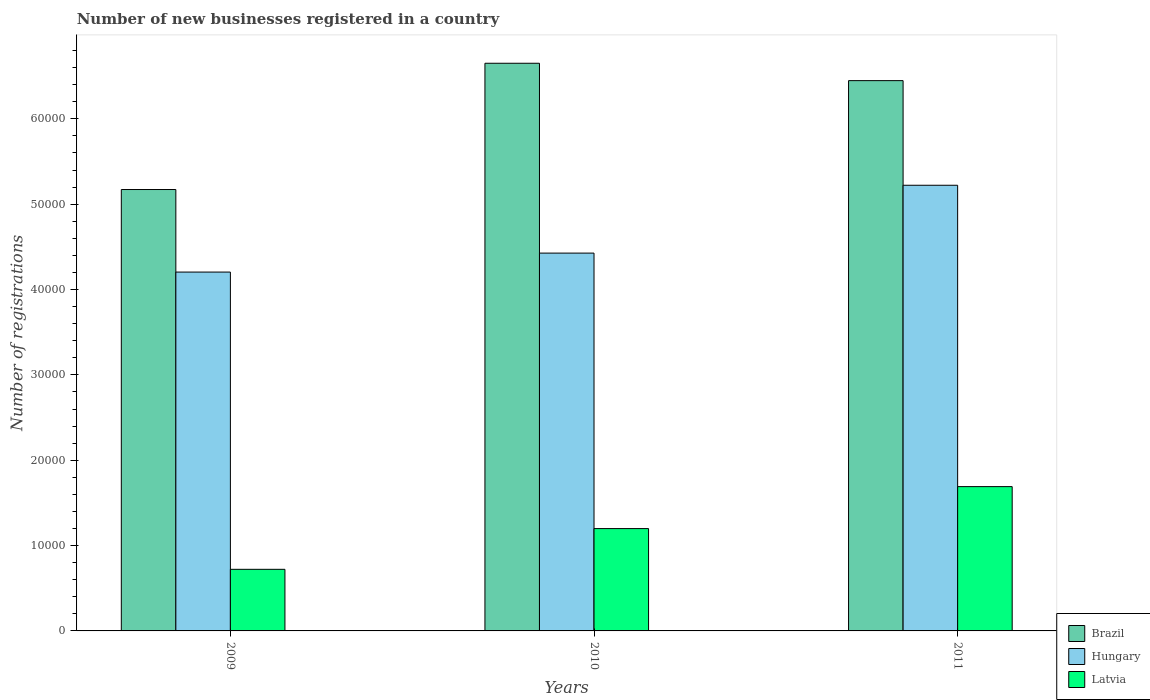How many groups of bars are there?
Offer a very short reply. 3. Are the number of bars on each tick of the X-axis equal?
Offer a terse response. Yes. How many bars are there on the 2nd tick from the left?
Provide a succinct answer. 3. What is the label of the 3rd group of bars from the left?
Provide a succinct answer. 2011. What is the number of new businesses registered in Brazil in 2011?
Ensure brevity in your answer.  6.45e+04. Across all years, what is the maximum number of new businesses registered in Hungary?
Keep it short and to the point. 5.22e+04. Across all years, what is the minimum number of new businesses registered in Hungary?
Your response must be concise. 4.20e+04. What is the total number of new businesses registered in Latvia in the graph?
Offer a very short reply. 3.61e+04. What is the difference between the number of new businesses registered in Brazil in 2009 and that in 2011?
Make the answer very short. -1.28e+04. What is the difference between the number of new businesses registered in Latvia in 2011 and the number of new businesses registered in Hungary in 2010?
Make the answer very short. -2.74e+04. What is the average number of new businesses registered in Hungary per year?
Ensure brevity in your answer.  4.62e+04. In the year 2011, what is the difference between the number of new businesses registered in Hungary and number of new businesses registered in Brazil?
Provide a succinct answer. -1.23e+04. What is the ratio of the number of new businesses registered in Latvia in 2009 to that in 2011?
Your answer should be very brief. 0.43. Is the number of new businesses registered in Brazil in 2010 less than that in 2011?
Provide a short and direct response. No. What is the difference between the highest and the second highest number of new businesses registered in Latvia?
Your answer should be very brief. 4918. What is the difference between the highest and the lowest number of new businesses registered in Latvia?
Make the answer very short. 9690. Is the sum of the number of new businesses registered in Latvia in 2010 and 2011 greater than the maximum number of new businesses registered in Hungary across all years?
Give a very brief answer. No. What does the 1st bar from the left in 2009 represents?
Provide a short and direct response. Brazil. What does the 2nd bar from the right in 2011 represents?
Provide a succinct answer. Hungary. Is it the case that in every year, the sum of the number of new businesses registered in Brazil and number of new businesses registered in Hungary is greater than the number of new businesses registered in Latvia?
Provide a succinct answer. Yes. How many bars are there?
Your response must be concise. 9. Are all the bars in the graph horizontal?
Your answer should be very brief. No. Are the values on the major ticks of Y-axis written in scientific E-notation?
Give a very brief answer. No. Does the graph contain grids?
Make the answer very short. No. Where does the legend appear in the graph?
Offer a terse response. Bottom right. How many legend labels are there?
Ensure brevity in your answer.  3. What is the title of the graph?
Give a very brief answer. Number of new businesses registered in a country. Does "Cote d'Ivoire" appear as one of the legend labels in the graph?
Offer a terse response. No. What is the label or title of the X-axis?
Ensure brevity in your answer.  Years. What is the label or title of the Y-axis?
Keep it short and to the point. Number of registrations. What is the Number of registrations of Brazil in 2009?
Give a very brief answer. 5.17e+04. What is the Number of registrations in Hungary in 2009?
Ensure brevity in your answer.  4.20e+04. What is the Number of registrations in Latvia in 2009?
Keep it short and to the point. 7218. What is the Number of registrations of Brazil in 2010?
Make the answer very short. 6.65e+04. What is the Number of registrations in Hungary in 2010?
Provide a succinct answer. 4.43e+04. What is the Number of registrations of Latvia in 2010?
Your response must be concise. 1.20e+04. What is the Number of registrations of Brazil in 2011?
Offer a very short reply. 6.45e+04. What is the Number of registrations of Hungary in 2011?
Offer a terse response. 5.22e+04. What is the Number of registrations of Latvia in 2011?
Give a very brief answer. 1.69e+04. Across all years, what is the maximum Number of registrations in Brazil?
Provide a succinct answer. 6.65e+04. Across all years, what is the maximum Number of registrations of Hungary?
Your answer should be very brief. 5.22e+04. Across all years, what is the maximum Number of registrations of Latvia?
Offer a very short reply. 1.69e+04. Across all years, what is the minimum Number of registrations in Brazil?
Offer a very short reply. 5.17e+04. Across all years, what is the minimum Number of registrations in Hungary?
Keep it short and to the point. 4.20e+04. Across all years, what is the minimum Number of registrations in Latvia?
Ensure brevity in your answer.  7218. What is the total Number of registrations of Brazil in the graph?
Your answer should be very brief. 1.83e+05. What is the total Number of registrations of Hungary in the graph?
Offer a terse response. 1.39e+05. What is the total Number of registrations in Latvia in the graph?
Provide a succinct answer. 3.61e+04. What is the difference between the Number of registrations in Brazil in 2009 and that in 2010?
Provide a succinct answer. -1.48e+04. What is the difference between the Number of registrations of Hungary in 2009 and that in 2010?
Your answer should be very brief. -2223. What is the difference between the Number of registrations in Latvia in 2009 and that in 2010?
Provide a succinct answer. -4772. What is the difference between the Number of registrations of Brazil in 2009 and that in 2011?
Offer a very short reply. -1.28e+04. What is the difference between the Number of registrations in Hungary in 2009 and that in 2011?
Your response must be concise. -1.02e+04. What is the difference between the Number of registrations in Latvia in 2009 and that in 2011?
Offer a terse response. -9690. What is the difference between the Number of registrations in Brazil in 2010 and that in 2011?
Offer a terse response. 2036. What is the difference between the Number of registrations of Hungary in 2010 and that in 2011?
Your answer should be compact. -7948. What is the difference between the Number of registrations in Latvia in 2010 and that in 2011?
Provide a short and direct response. -4918. What is the difference between the Number of registrations of Brazil in 2009 and the Number of registrations of Hungary in 2010?
Provide a short and direct response. 7448. What is the difference between the Number of registrations in Brazil in 2009 and the Number of registrations in Latvia in 2010?
Your response must be concise. 3.97e+04. What is the difference between the Number of registrations in Hungary in 2009 and the Number of registrations in Latvia in 2010?
Your response must be concise. 3.01e+04. What is the difference between the Number of registrations in Brazil in 2009 and the Number of registrations in Hungary in 2011?
Your answer should be compact. -500. What is the difference between the Number of registrations of Brazil in 2009 and the Number of registrations of Latvia in 2011?
Keep it short and to the point. 3.48e+04. What is the difference between the Number of registrations of Hungary in 2009 and the Number of registrations of Latvia in 2011?
Ensure brevity in your answer.  2.51e+04. What is the difference between the Number of registrations of Brazil in 2010 and the Number of registrations of Hungary in 2011?
Your answer should be compact. 1.43e+04. What is the difference between the Number of registrations of Brazil in 2010 and the Number of registrations of Latvia in 2011?
Keep it short and to the point. 4.96e+04. What is the difference between the Number of registrations in Hungary in 2010 and the Number of registrations in Latvia in 2011?
Your response must be concise. 2.74e+04. What is the average Number of registrations in Brazil per year?
Ensure brevity in your answer.  6.09e+04. What is the average Number of registrations in Hungary per year?
Offer a terse response. 4.62e+04. What is the average Number of registrations in Latvia per year?
Provide a succinct answer. 1.20e+04. In the year 2009, what is the difference between the Number of registrations of Brazil and Number of registrations of Hungary?
Your response must be concise. 9671. In the year 2009, what is the difference between the Number of registrations of Brazil and Number of registrations of Latvia?
Ensure brevity in your answer.  4.45e+04. In the year 2009, what is the difference between the Number of registrations in Hungary and Number of registrations in Latvia?
Provide a succinct answer. 3.48e+04. In the year 2010, what is the difference between the Number of registrations in Brazil and Number of registrations in Hungary?
Your answer should be compact. 2.22e+04. In the year 2010, what is the difference between the Number of registrations in Brazil and Number of registrations in Latvia?
Offer a terse response. 5.45e+04. In the year 2010, what is the difference between the Number of registrations of Hungary and Number of registrations of Latvia?
Your answer should be compact. 3.23e+04. In the year 2011, what is the difference between the Number of registrations of Brazil and Number of registrations of Hungary?
Your response must be concise. 1.23e+04. In the year 2011, what is the difference between the Number of registrations in Brazil and Number of registrations in Latvia?
Keep it short and to the point. 4.76e+04. In the year 2011, what is the difference between the Number of registrations of Hungary and Number of registrations of Latvia?
Provide a succinct answer. 3.53e+04. What is the ratio of the Number of registrations in Brazil in 2009 to that in 2010?
Offer a terse response. 0.78. What is the ratio of the Number of registrations of Hungary in 2009 to that in 2010?
Offer a terse response. 0.95. What is the ratio of the Number of registrations in Latvia in 2009 to that in 2010?
Your answer should be very brief. 0.6. What is the ratio of the Number of registrations in Brazil in 2009 to that in 2011?
Give a very brief answer. 0.8. What is the ratio of the Number of registrations in Hungary in 2009 to that in 2011?
Give a very brief answer. 0.81. What is the ratio of the Number of registrations in Latvia in 2009 to that in 2011?
Your response must be concise. 0.43. What is the ratio of the Number of registrations of Brazil in 2010 to that in 2011?
Offer a very short reply. 1.03. What is the ratio of the Number of registrations of Hungary in 2010 to that in 2011?
Ensure brevity in your answer.  0.85. What is the ratio of the Number of registrations in Latvia in 2010 to that in 2011?
Provide a short and direct response. 0.71. What is the difference between the highest and the second highest Number of registrations of Brazil?
Your answer should be very brief. 2036. What is the difference between the highest and the second highest Number of registrations of Hungary?
Give a very brief answer. 7948. What is the difference between the highest and the second highest Number of registrations in Latvia?
Offer a very short reply. 4918. What is the difference between the highest and the lowest Number of registrations in Brazil?
Provide a short and direct response. 1.48e+04. What is the difference between the highest and the lowest Number of registrations of Hungary?
Give a very brief answer. 1.02e+04. What is the difference between the highest and the lowest Number of registrations of Latvia?
Your response must be concise. 9690. 